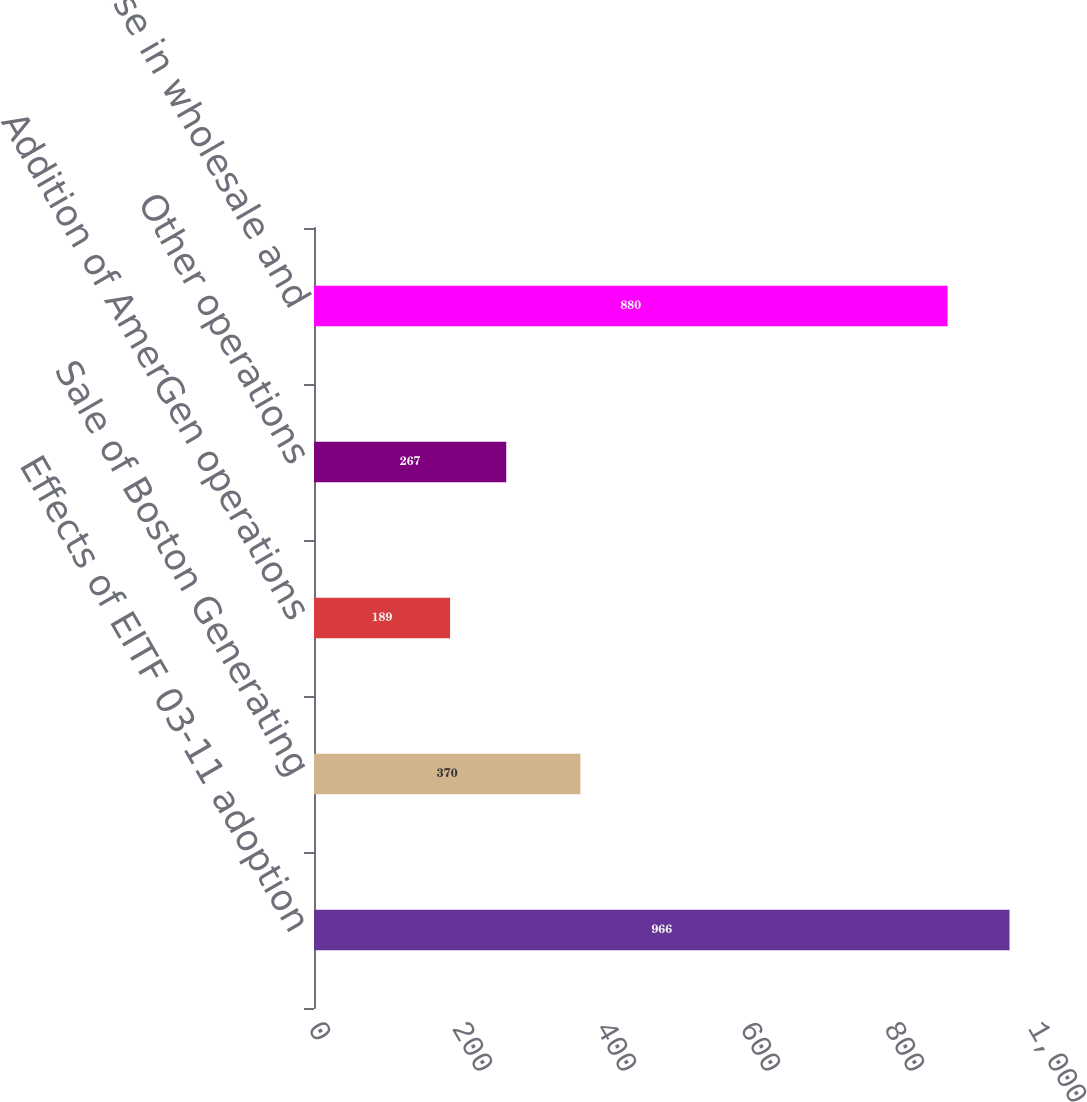Convert chart. <chart><loc_0><loc_0><loc_500><loc_500><bar_chart><fcel>Effects of EITF 03-11 adoption<fcel>Sale of Boston Generating<fcel>Addition of AmerGen operations<fcel>Other operations<fcel>Decrease in wholesale and<nl><fcel>966<fcel>370<fcel>189<fcel>267<fcel>880<nl></chart> 